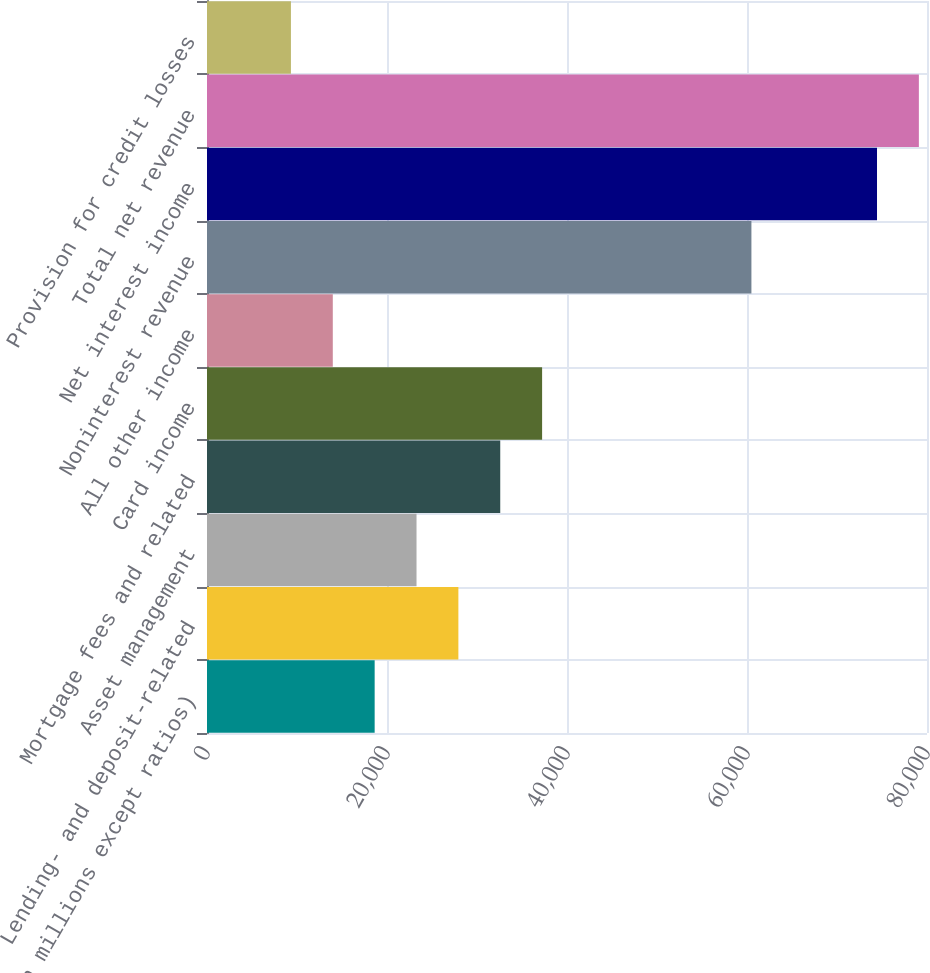Convert chart. <chart><loc_0><loc_0><loc_500><loc_500><bar_chart><fcel>(in millions except ratios)<fcel>Lending- and deposit-related<fcel>Asset management<fcel>Mortgage fees and related<fcel>Card income<fcel>All other income<fcel>Noninterest revenue<fcel>Net interest income<fcel>Total net revenue<fcel>Provision for credit losses<nl><fcel>18628.6<fcel>27931.4<fcel>23280<fcel>32582.8<fcel>37234.2<fcel>13977.2<fcel>60491.2<fcel>74445.4<fcel>79096.8<fcel>9325.8<nl></chart> 